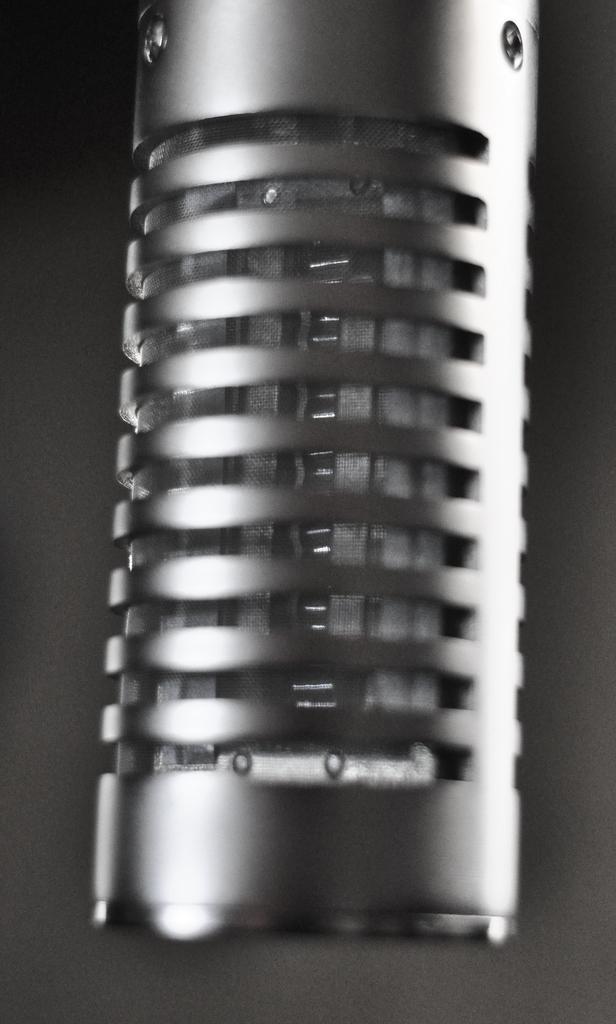Describe this image in one or two sentences. In this image, we can see a microphone. 